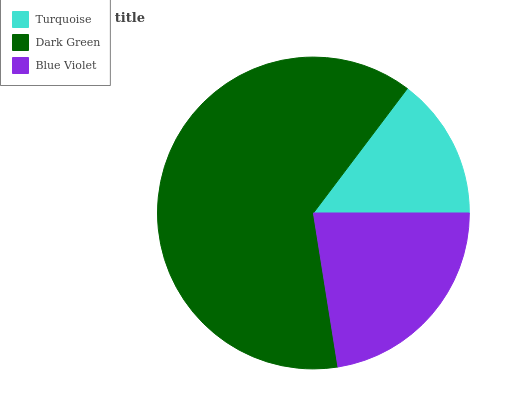Is Turquoise the minimum?
Answer yes or no. Yes. Is Dark Green the maximum?
Answer yes or no. Yes. Is Blue Violet the minimum?
Answer yes or no. No. Is Blue Violet the maximum?
Answer yes or no. No. Is Dark Green greater than Blue Violet?
Answer yes or no. Yes. Is Blue Violet less than Dark Green?
Answer yes or no. Yes. Is Blue Violet greater than Dark Green?
Answer yes or no. No. Is Dark Green less than Blue Violet?
Answer yes or no. No. Is Blue Violet the high median?
Answer yes or no. Yes. Is Blue Violet the low median?
Answer yes or no. Yes. Is Turquoise the high median?
Answer yes or no. No. Is Turquoise the low median?
Answer yes or no. No. 